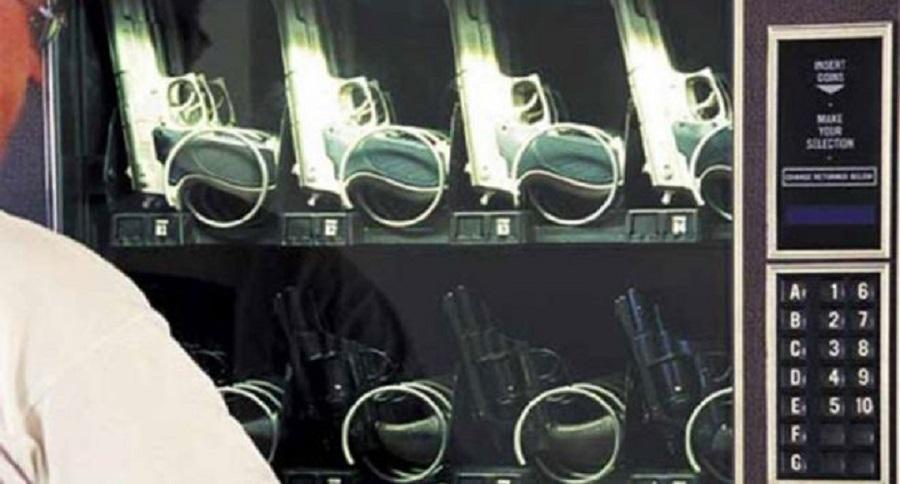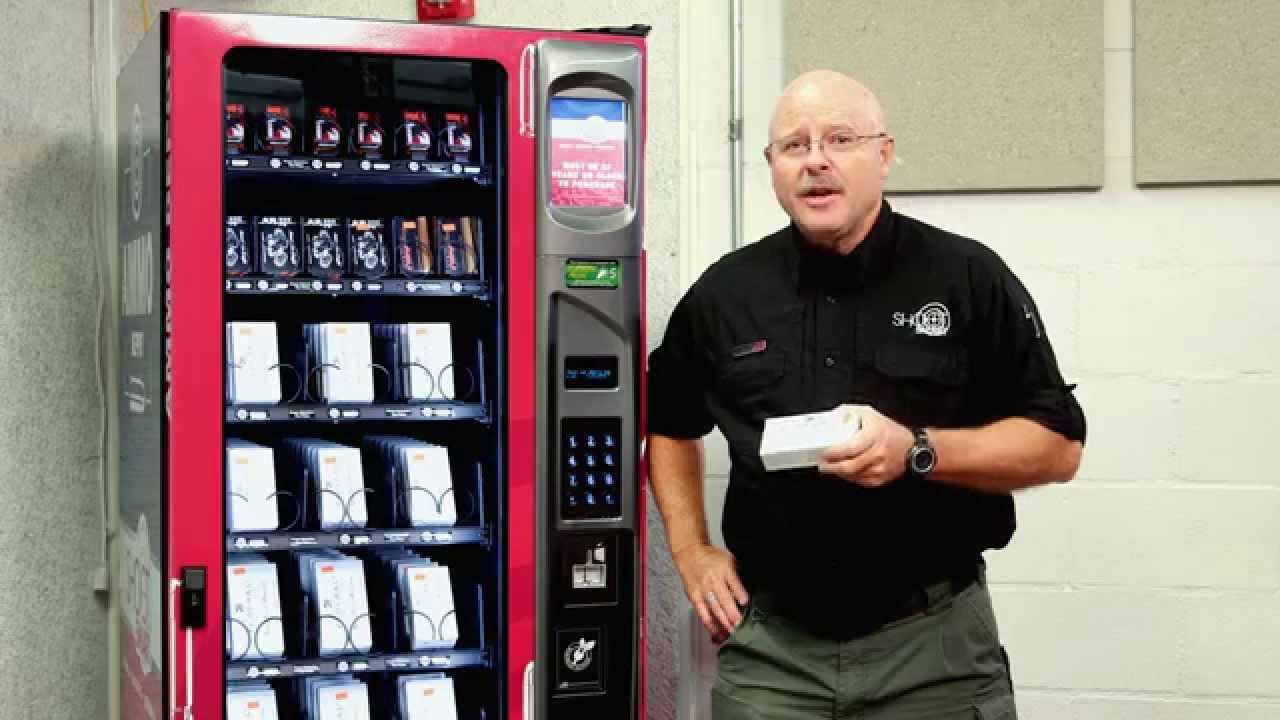The first image is the image on the left, the second image is the image on the right. For the images shown, is this caption "One of these machines is red." true? Answer yes or no. Yes. 